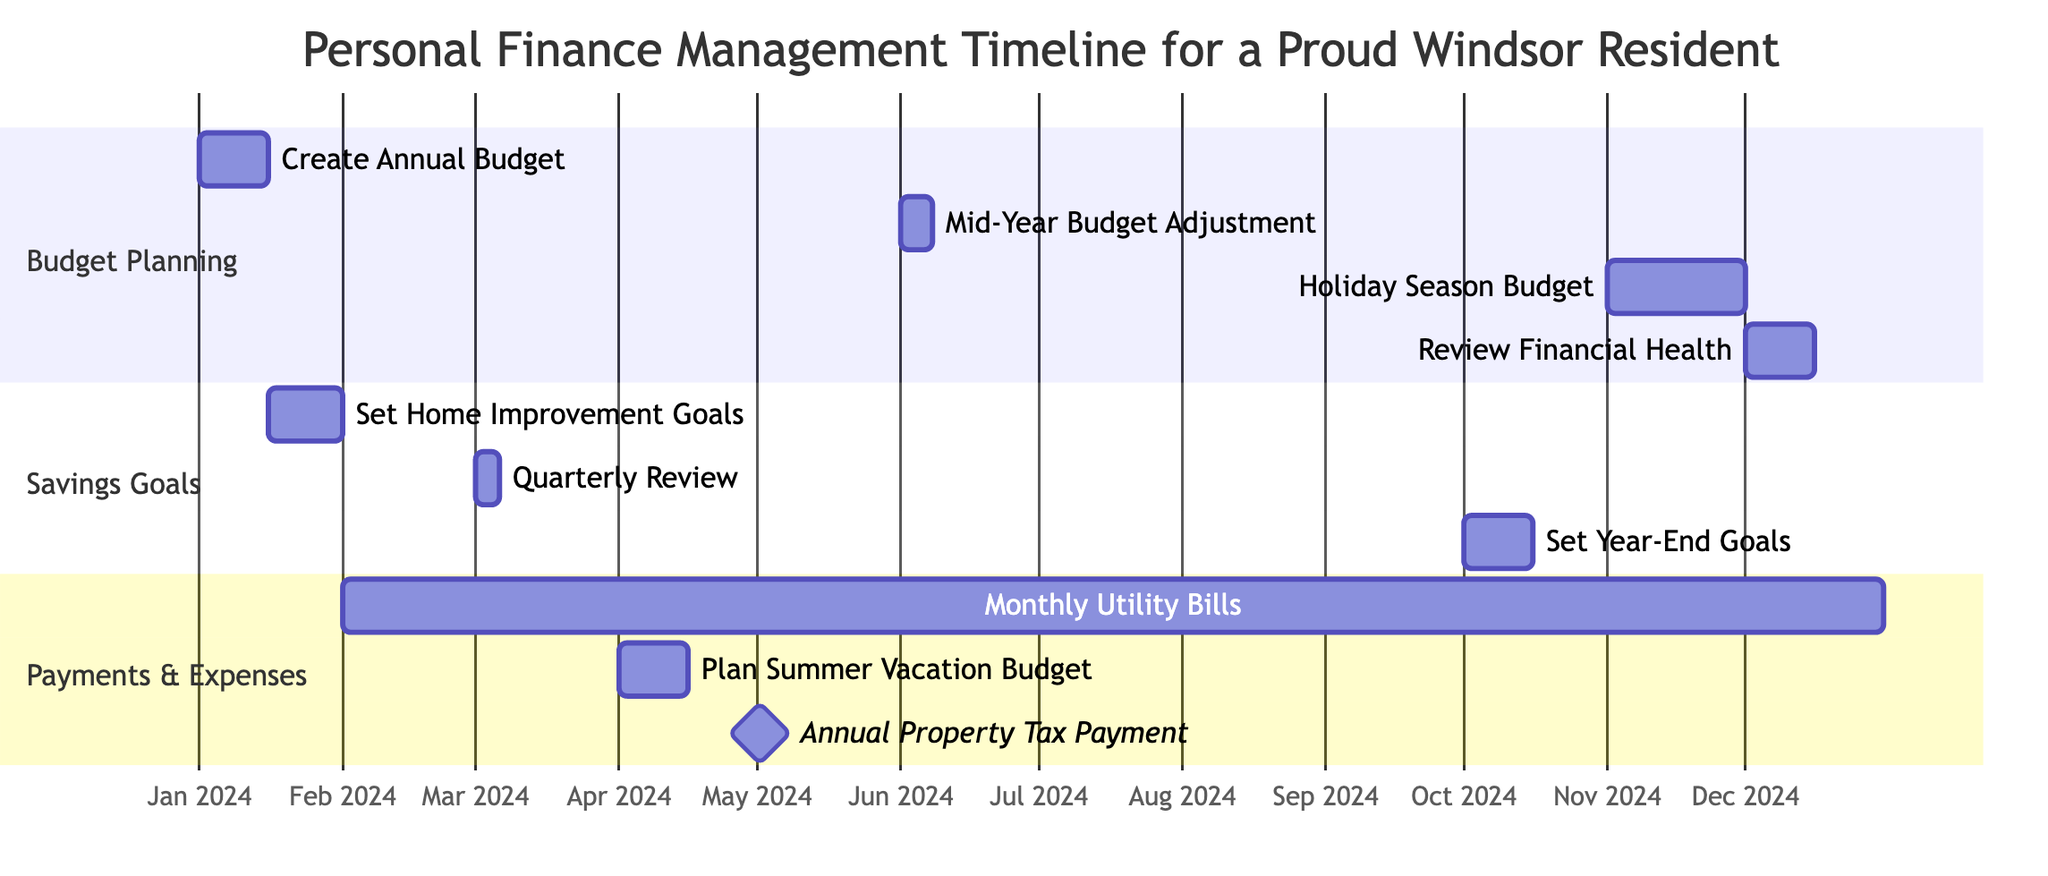What is the duration for creating the annual budget? The task "Create Annual Budget" starts on January 1, 2024, and ends on January 15, 2024. This results in a duration of 15 days.
Answer: 15 days How many tasks are planned for budgeting? The section "Budget Planning" includes four tasks: "Create Annual Budget," "Mid-Year Budget Adjustment," "Holiday Season Budget," and "Review Financial Health." Counting these, we find there are 4 tasks.
Answer: 4 tasks What is the frequency of utility bill payments? The task "Monthly Utility Bill Payments" is specified to occur monthly from February 1, 2024, until December 31, 2024, indicating that the frequency is monthly.
Answer: monthly Which task overlaps with the holiday season budget? The "Holiday Season Budget" starts on November 1, 2024, and ends on November 30, 2024. The “Review Overall Financial Health” task starts right after on December 1 and it does not overlap; thus, there are no overlapping tasks.
Answer: None When is the mid-year budget adjustment scheduled? The task "Mid-Year Budget Adjustment" is scheduled from June 1, 2024, to June 7, 2024, as noted in the Gantt chart.
Answer: June 1 to June 7, 2024 How many total sections are in the Gantt chart? The Gantt chart has three sections labeled: "Budget Planning," "Savings Goals," and "Payments & Expenses." Counting these sections, we find there are 3 sections.
Answer: 3 sections What is the end date for the savings goal review? The "Quarterly Review of Savings Progress" task is set to end on March 5, 2024, as specified in the timeline.
Answer: March 5, 2024 What two tasks occur in April? The two tasks in April are "Plan Summer Vacation Budget," which runs from April 1 to April 15, and is the only task scheduled for that month based on the diagram.
Answer: Plan Summer Vacation Budget How many total tasks are planned from October to December? Reviewing the tasks from October to December, we see "Set Year-End Savings Goals," "Holiday Season Budget," and "Review Overall Financial Health," which totals to three tasks.
Answer: 3 tasks 